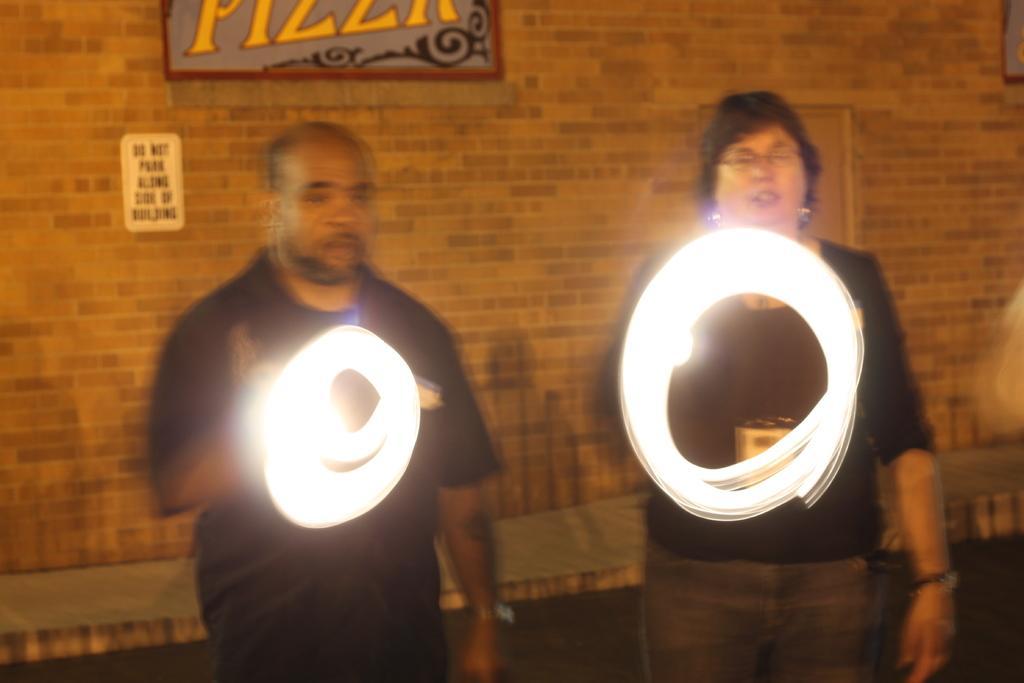How would you summarize this image in a sentence or two? In this image, we can see persons in front of the wall. These persons are wearing clothes and holding lights with their hands. There is a board at the top of the image. 